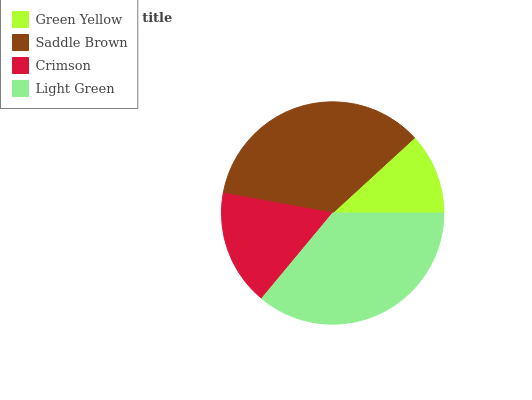Is Green Yellow the minimum?
Answer yes or no. Yes. Is Light Green the maximum?
Answer yes or no. Yes. Is Saddle Brown the minimum?
Answer yes or no. No. Is Saddle Brown the maximum?
Answer yes or no. No. Is Saddle Brown greater than Green Yellow?
Answer yes or no. Yes. Is Green Yellow less than Saddle Brown?
Answer yes or no. Yes. Is Green Yellow greater than Saddle Brown?
Answer yes or no. No. Is Saddle Brown less than Green Yellow?
Answer yes or no. No. Is Saddle Brown the high median?
Answer yes or no. Yes. Is Crimson the low median?
Answer yes or no. Yes. Is Light Green the high median?
Answer yes or no. No. Is Light Green the low median?
Answer yes or no. No. 